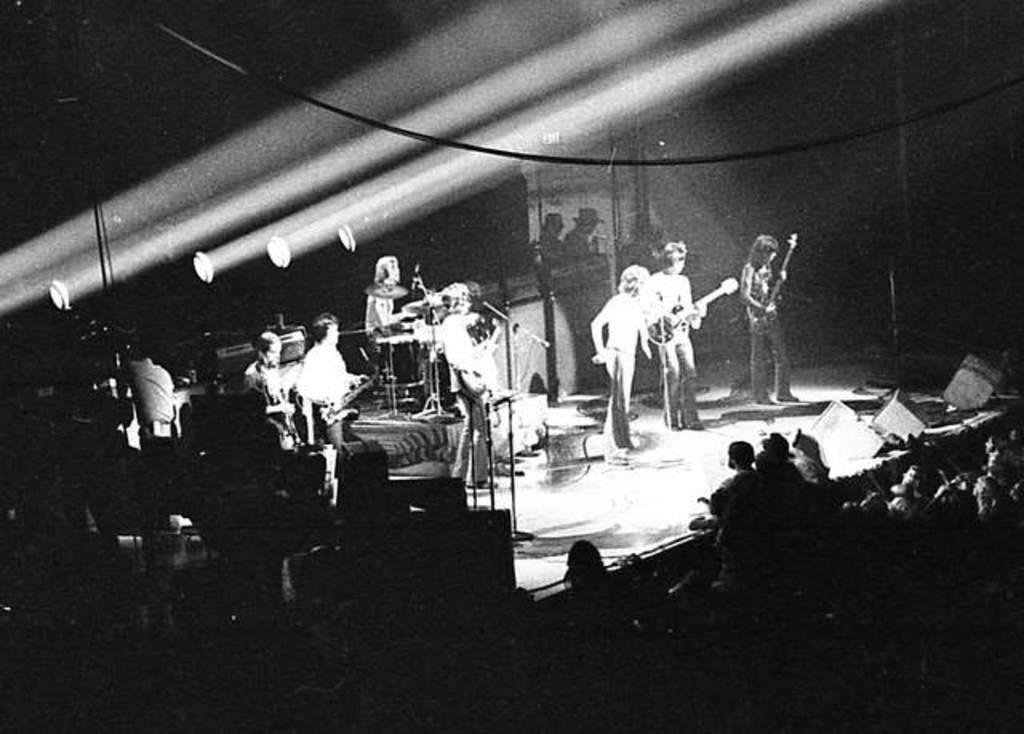How would you summarize this image in a sentence or two? It is a black and white image and in this image we can see a few people playing the musical instruments and standing on the stage. We can also see the other people watching. Image also consists of lights and also wires. 